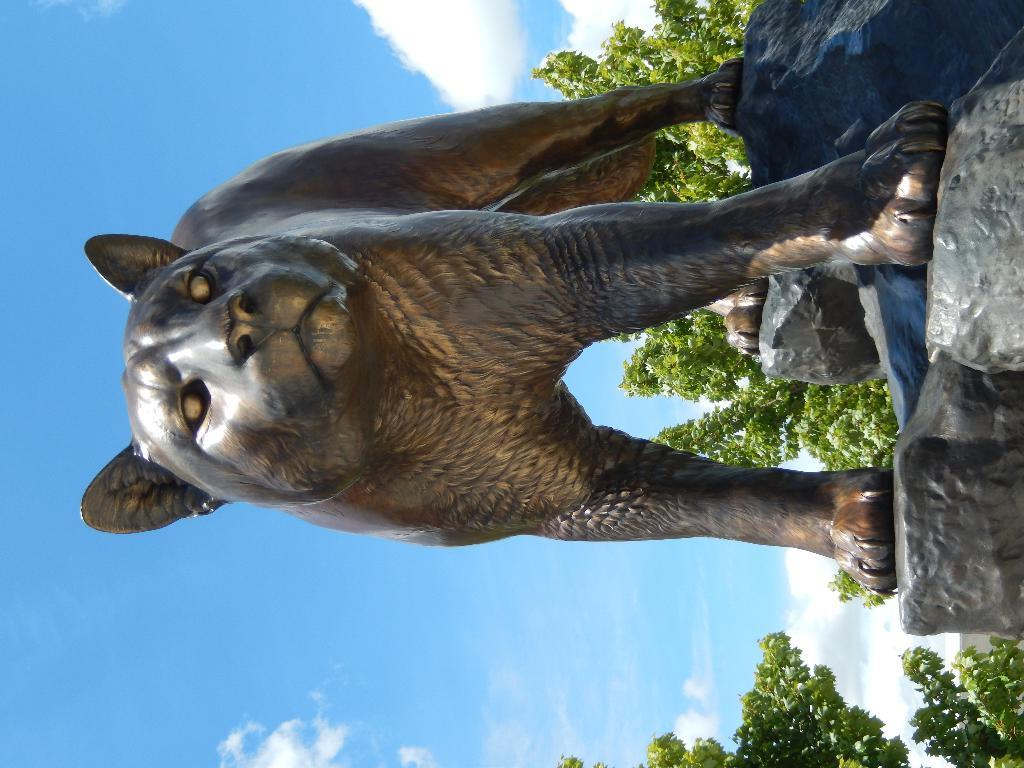What is located on the rocks in the image? There is a sculpture on the rocks in the image. What type of vegetation can be seen in the image? There are trees in the image. What is visible in the background of the image? The sky is visible in the background of the image. What can be observed in the sky? Clouds are present in the sky. What type of tail can be seen on the sculpture in the image? There is no tail present on the sculpture in the image. What surprise event is happening in the image? There is no surprise event depicted in the image. 